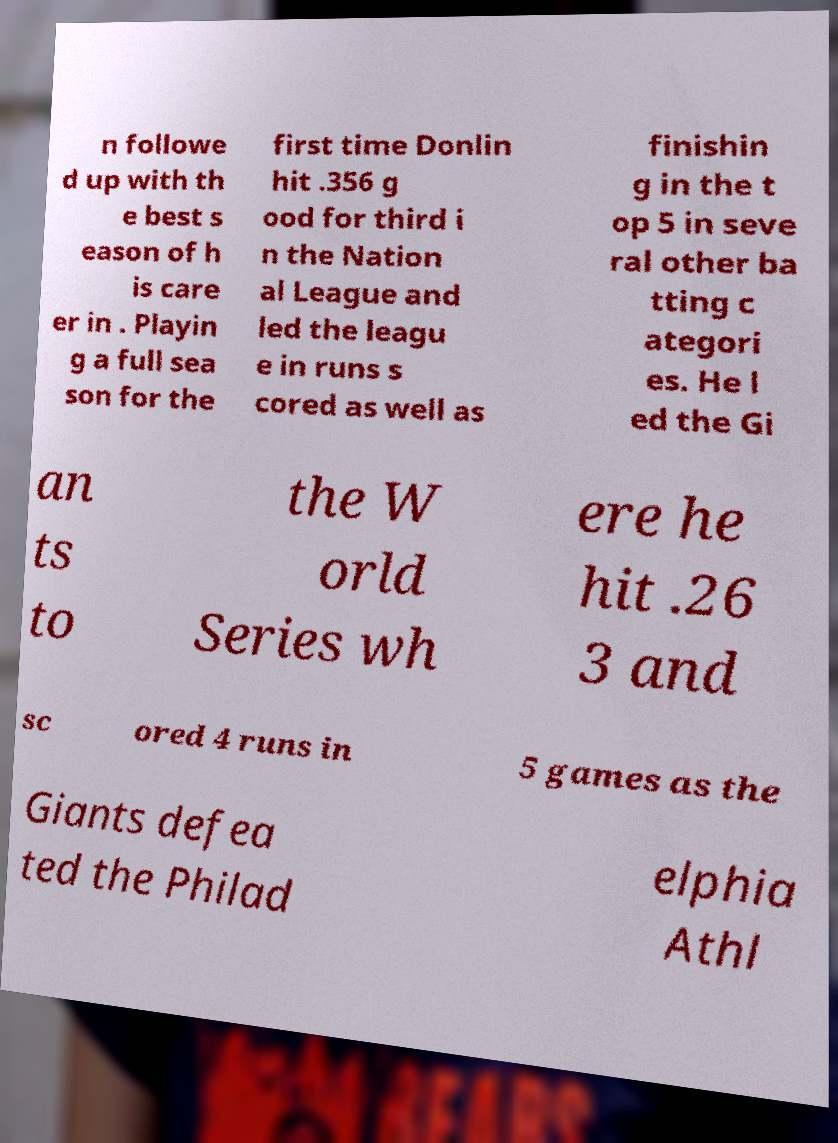Please read and relay the text visible in this image. What does it say? n followe d up with th e best s eason of h is care er in . Playin g a full sea son for the first time Donlin hit .356 g ood for third i n the Nation al League and led the leagu e in runs s cored as well as finishin g in the t op 5 in seve ral other ba tting c ategori es. He l ed the Gi an ts to the W orld Series wh ere he hit .26 3 and sc ored 4 runs in 5 games as the Giants defea ted the Philad elphia Athl 